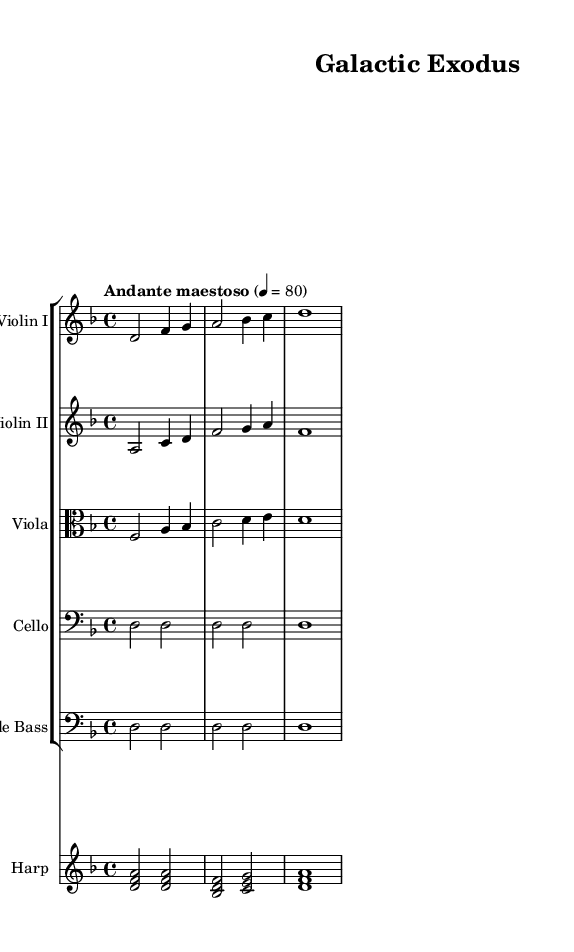What is the key signature of this music? The key signature is indicated at the beginning of the score and shows two flats, which means the key is D minor.
Answer: D minor What is the time signature of this music? The time signature is stated at the beginning of the score as 4/4, indicating four beats per measure.
Answer: 4/4 What is the tempo marking for this piece? The tempo marking is written as "Andante maestoso," which describes a moderate, stately pace for the music.
Answer: Andante maestoso How many measures are in the violin I part? By counting the measures in the violin I part, there are four distinct measures present.
Answer: Four measures What is the highest note played by the harp? The highest note in the harp part is A, which is represented in the third measure of its section.
Answer: A What instrument plays the lowest part in this score? The double bass is the instrument that plays the lowest part, as it is notated in the bass clef and provides the foundation for the harmony.
Answer: Double bass How does the melody in violin I interact with the melody in violin II? The melody in violin I moves primarily in the higher range while the violin II harmonizes below it, creating a fuller texture.
Answer: They harmonize together 